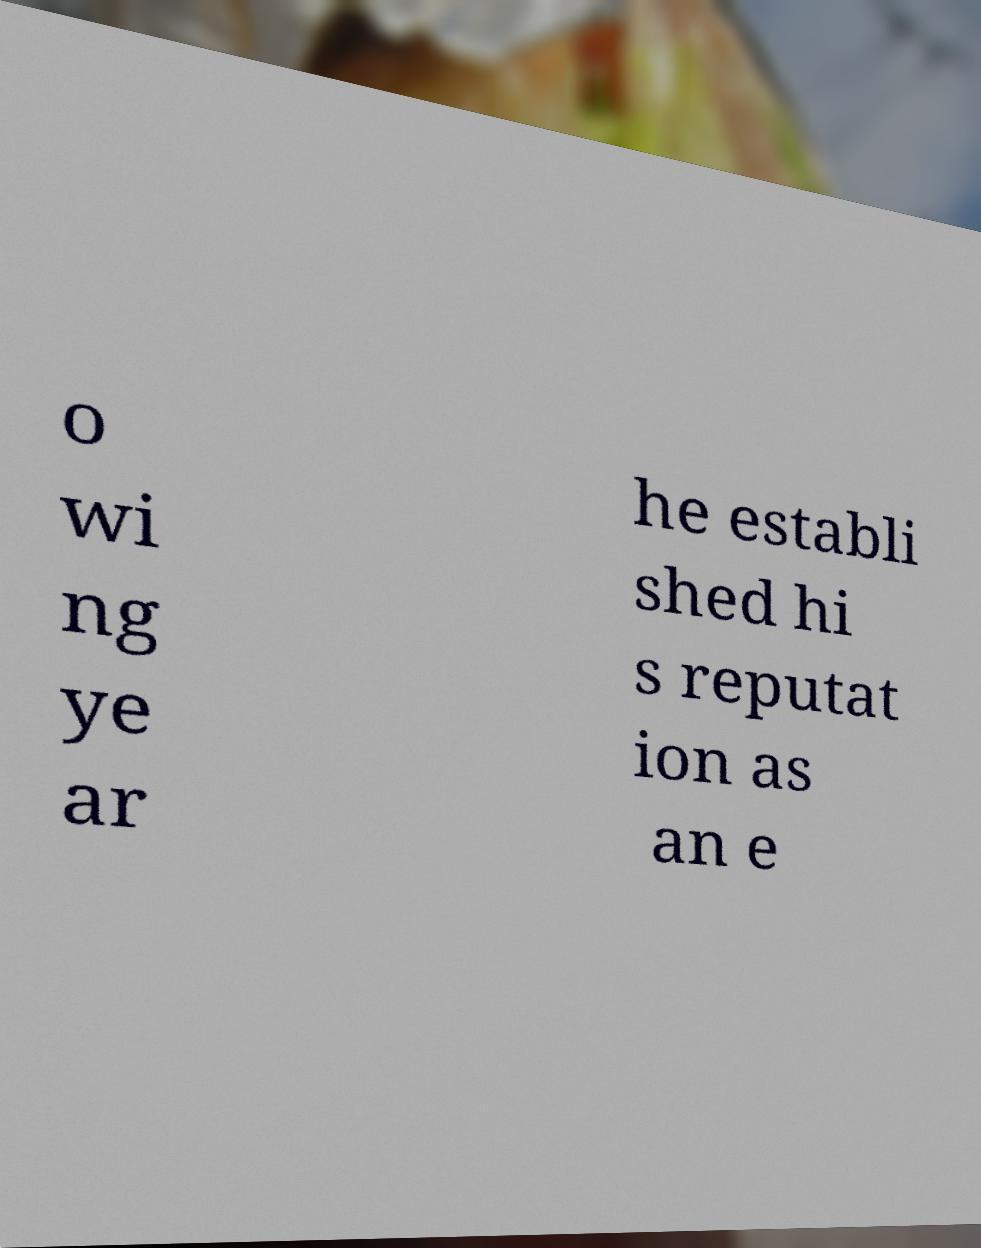For documentation purposes, I need the text within this image transcribed. Could you provide that? o wi ng ye ar he establi shed hi s reputat ion as an e 